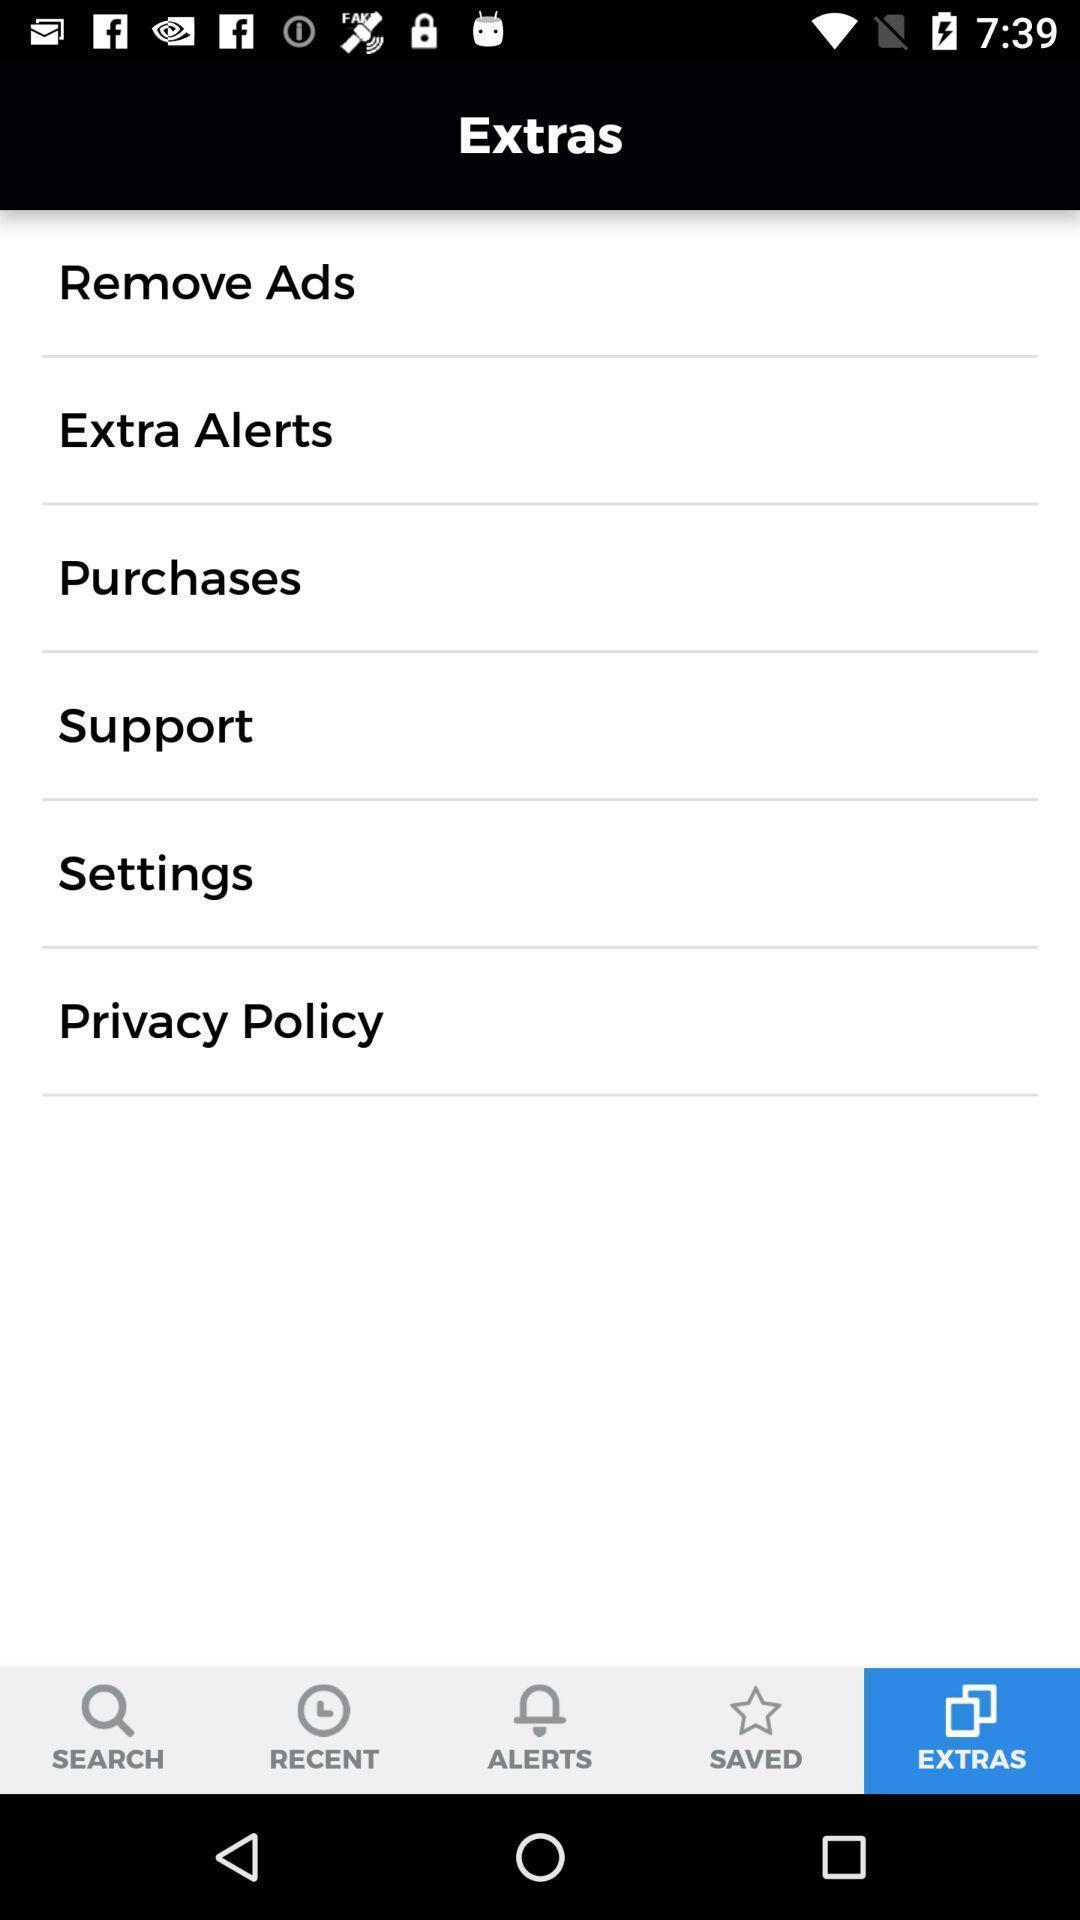Provide a textual representation of this image. Window displaying a page with different options. 